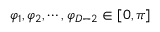Convert formula to latex. <formula><loc_0><loc_0><loc_500><loc_500>\varphi _ { 1 } , \varphi _ { 2 } , \cdots , \varphi _ { D - 2 } \in [ 0 , \pi ]</formula> 